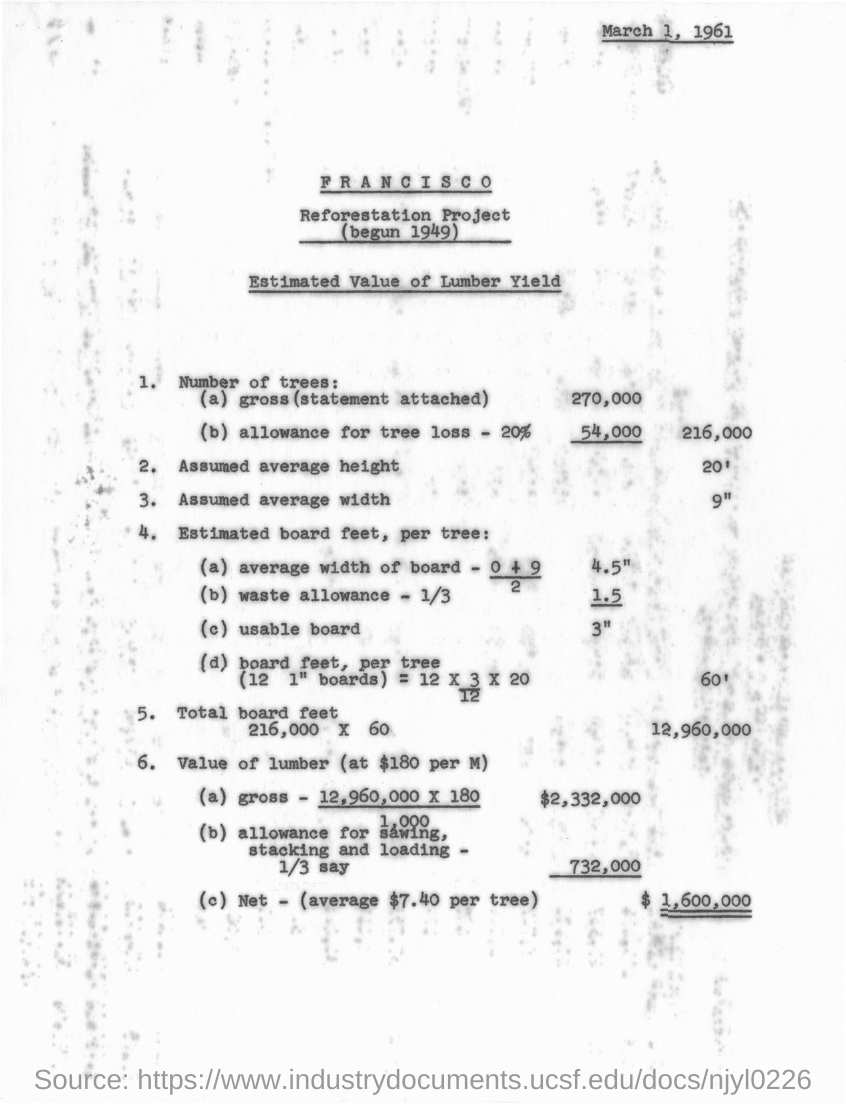Point out several critical features in this image. The reforestation project began in 1949. It is assumed that the average height is 20 feet. The document is dated March 1, 1961. The net value of lumber is estimated to be $1,600,000. 